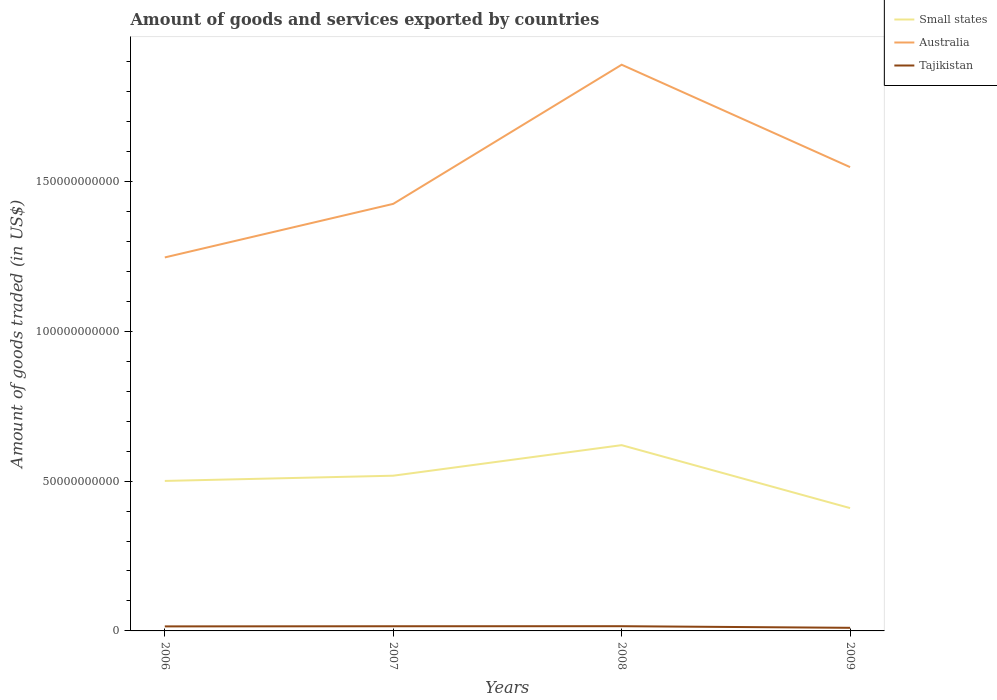How many different coloured lines are there?
Offer a very short reply. 3. Does the line corresponding to Australia intersect with the line corresponding to Small states?
Your answer should be very brief. No. Across all years, what is the maximum total amount of goods and services exported in Tajikistan?
Your answer should be compact. 1.04e+09. In which year was the total amount of goods and services exported in Small states maximum?
Your answer should be very brief. 2009. What is the total total amount of goods and services exported in Australia in the graph?
Offer a very short reply. -6.43e+1. What is the difference between the highest and the second highest total amount of goods and services exported in Tajikistan?
Make the answer very short. 5.36e+08. How many years are there in the graph?
Provide a short and direct response. 4. What is the difference between two consecutive major ticks on the Y-axis?
Your response must be concise. 5.00e+1. Does the graph contain any zero values?
Make the answer very short. No. Where does the legend appear in the graph?
Give a very brief answer. Top right. How many legend labels are there?
Offer a terse response. 3. How are the legend labels stacked?
Make the answer very short. Vertical. What is the title of the graph?
Offer a very short reply. Amount of goods and services exported by countries. Does "Sri Lanka" appear as one of the legend labels in the graph?
Give a very brief answer. No. What is the label or title of the Y-axis?
Your response must be concise. Amount of goods traded (in US$). What is the Amount of goods traded (in US$) of Small states in 2006?
Offer a very short reply. 5.01e+1. What is the Amount of goods traded (in US$) of Australia in 2006?
Provide a succinct answer. 1.25e+11. What is the Amount of goods traded (in US$) of Tajikistan in 2006?
Keep it short and to the point. 1.51e+09. What is the Amount of goods traded (in US$) of Small states in 2007?
Ensure brevity in your answer.  5.18e+1. What is the Amount of goods traded (in US$) of Australia in 2007?
Your response must be concise. 1.43e+11. What is the Amount of goods traded (in US$) in Tajikistan in 2007?
Keep it short and to the point. 1.56e+09. What is the Amount of goods traded (in US$) of Small states in 2008?
Keep it short and to the point. 6.20e+1. What is the Amount of goods traded (in US$) in Australia in 2008?
Your answer should be very brief. 1.89e+11. What is the Amount of goods traded (in US$) of Tajikistan in 2008?
Ensure brevity in your answer.  1.57e+09. What is the Amount of goods traded (in US$) of Small states in 2009?
Your answer should be compact. 4.10e+1. What is the Amount of goods traded (in US$) of Australia in 2009?
Your answer should be compact. 1.55e+11. What is the Amount of goods traded (in US$) in Tajikistan in 2009?
Provide a succinct answer. 1.04e+09. Across all years, what is the maximum Amount of goods traded (in US$) in Small states?
Make the answer very short. 6.20e+1. Across all years, what is the maximum Amount of goods traded (in US$) in Australia?
Your response must be concise. 1.89e+11. Across all years, what is the maximum Amount of goods traded (in US$) in Tajikistan?
Your answer should be very brief. 1.57e+09. Across all years, what is the minimum Amount of goods traded (in US$) of Small states?
Provide a short and direct response. 4.10e+1. Across all years, what is the minimum Amount of goods traded (in US$) in Australia?
Ensure brevity in your answer.  1.25e+11. Across all years, what is the minimum Amount of goods traded (in US$) in Tajikistan?
Offer a terse response. 1.04e+09. What is the total Amount of goods traded (in US$) of Small states in the graph?
Provide a succinct answer. 2.05e+11. What is the total Amount of goods traded (in US$) in Australia in the graph?
Provide a succinct answer. 6.11e+11. What is the total Amount of goods traded (in US$) of Tajikistan in the graph?
Your answer should be compact. 5.68e+09. What is the difference between the Amount of goods traded (in US$) in Small states in 2006 and that in 2007?
Offer a terse response. -1.74e+09. What is the difference between the Amount of goods traded (in US$) of Australia in 2006 and that in 2007?
Make the answer very short. -1.79e+1. What is the difference between the Amount of goods traded (in US$) of Tajikistan in 2006 and that in 2007?
Provide a succinct answer. -4.51e+07. What is the difference between the Amount of goods traded (in US$) in Small states in 2006 and that in 2008?
Offer a very short reply. -1.19e+1. What is the difference between the Amount of goods traded (in US$) in Australia in 2006 and that in 2008?
Provide a short and direct response. -6.43e+1. What is the difference between the Amount of goods traded (in US$) in Tajikistan in 2006 and that in 2008?
Your answer should be compact. -6.31e+07. What is the difference between the Amount of goods traded (in US$) of Small states in 2006 and that in 2009?
Provide a short and direct response. 9.06e+09. What is the difference between the Amount of goods traded (in US$) in Australia in 2006 and that in 2009?
Keep it short and to the point. -3.01e+1. What is the difference between the Amount of goods traded (in US$) in Tajikistan in 2006 and that in 2009?
Your answer should be compact. 4.73e+08. What is the difference between the Amount of goods traded (in US$) of Small states in 2007 and that in 2008?
Ensure brevity in your answer.  -1.02e+1. What is the difference between the Amount of goods traded (in US$) in Australia in 2007 and that in 2008?
Give a very brief answer. -4.64e+1. What is the difference between the Amount of goods traded (in US$) of Tajikistan in 2007 and that in 2008?
Give a very brief answer. -1.80e+07. What is the difference between the Amount of goods traded (in US$) of Small states in 2007 and that in 2009?
Your response must be concise. 1.08e+1. What is the difference between the Amount of goods traded (in US$) in Australia in 2007 and that in 2009?
Keep it short and to the point. -1.23e+1. What is the difference between the Amount of goods traded (in US$) of Tajikistan in 2007 and that in 2009?
Your response must be concise. 5.18e+08. What is the difference between the Amount of goods traded (in US$) of Small states in 2008 and that in 2009?
Your answer should be compact. 2.10e+1. What is the difference between the Amount of goods traded (in US$) in Australia in 2008 and that in 2009?
Provide a succinct answer. 3.42e+1. What is the difference between the Amount of goods traded (in US$) of Tajikistan in 2008 and that in 2009?
Keep it short and to the point. 5.36e+08. What is the difference between the Amount of goods traded (in US$) in Small states in 2006 and the Amount of goods traded (in US$) in Australia in 2007?
Your answer should be very brief. -9.25e+1. What is the difference between the Amount of goods traded (in US$) in Small states in 2006 and the Amount of goods traded (in US$) in Tajikistan in 2007?
Keep it short and to the point. 4.85e+1. What is the difference between the Amount of goods traded (in US$) in Australia in 2006 and the Amount of goods traded (in US$) in Tajikistan in 2007?
Offer a very short reply. 1.23e+11. What is the difference between the Amount of goods traded (in US$) of Small states in 2006 and the Amount of goods traded (in US$) of Australia in 2008?
Provide a short and direct response. -1.39e+11. What is the difference between the Amount of goods traded (in US$) of Small states in 2006 and the Amount of goods traded (in US$) of Tajikistan in 2008?
Ensure brevity in your answer.  4.85e+1. What is the difference between the Amount of goods traded (in US$) in Australia in 2006 and the Amount of goods traded (in US$) in Tajikistan in 2008?
Provide a short and direct response. 1.23e+11. What is the difference between the Amount of goods traded (in US$) in Small states in 2006 and the Amount of goods traded (in US$) in Australia in 2009?
Your answer should be very brief. -1.05e+11. What is the difference between the Amount of goods traded (in US$) in Small states in 2006 and the Amount of goods traded (in US$) in Tajikistan in 2009?
Give a very brief answer. 4.90e+1. What is the difference between the Amount of goods traded (in US$) in Australia in 2006 and the Amount of goods traded (in US$) in Tajikistan in 2009?
Provide a short and direct response. 1.24e+11. What is the difference between the Amount of goods traded (in US$) of Small states in 2007 and the Amount of goods traded (in US$) of Australia in 2008?
Make the answer very short. -1.37e+11. What is the difference between the Amount of goods traded (in US$) in Small states in 2007 and the Amount of goods traded (in US$) in Tajikistan in 2008?
Make the answer very short. 5.02e+1. What is the difference between the Amount of goods traded (in US$) in Australia in 2007 and the Amount of goods traded (in US$) in Tajikistan in 2008?
Your answer should be very brief. 1.41e+11. What is the difference between the Amount of goods traded (in US$) of Small states in 2007 and the Amount of goods traded (in US$) of Australia in 2009?
Keep it short and to the point. -1.03e+11. What is the difference between the Amount of goods traded (in US$) of Small states in 2007 and the Amount of goods traded (in US$) of Tajikistan in 2009?
Offer a very short reply. 5.08e+1. What is the difference between the Amount of goods traded (in US$) in Australia in 2007 and the Amount of goods traded (in US$) in Tajikistan in 2009?
Provide a succinct answer. 1.41e+11. What is the difference between the Amount of goods traded (in US$) in Small states in 2008 and the Amount of goods traded (in US$) in Australia in 2009?
Provide a short and direct response. -9.28e+1. What is the difference between the Amount of goods traded (in US$) in Small states in 2008 and the Amount of goods traded (in US$) in Tajikistan in 2009?
Your answer should be very brief. 6.10e+1. What is the difference between the Amount of goods traded (in US$) in Australia in 2008 and the Amount of goods traded (in US$) in Tajikistan in 2009?
Provide a succinct answer. 1.88e+11. What is the average Amount of goods traded (in US$) in Small states per year?
Provide a succinct answer. 5.12e+1. What is the average Amount of goods traded (in US$) of Australia per year?
Offer a very short reply. 1.53e+11. What is the average Amount of goods traded (in US$) in Tajikistan per year?
Your answer should be very brief. 1.42e+09. In the year 2006, what is the difference between the Amount of goods traded (in US$) of Small states and Amount of goods traded (in US$) of Australia?
Keep it short and to the point. -7.46e+1. In the year 2006, what is the difference between the Amount of goods traded (in US$) of Small states and Amount of goods traded (in US$) of Tajikistan?
Keep it short and to the point. 4.85e+1. In the year 2006, what is the difference between the Amount of goods traded (in US$) of Australia and Amount of goods traded (in US$) of Tajikistan?
Make the answer very short. 1.23e+11. In the year 2007, what is the difference between the Amount of goods traded (in US$) of Small states and Amount of goods traded (in US$) of Australia?
Keep it short and to the point. -9.07e+1. In the year 2007, what is the difference between the Amount of goods traded (in US$) in Small states and Amount of goods traded (in US$) in Tajikistan?
Make the answer very short. 5.02e+1. In the year 2007, what is the difference between the Amount of goods traded (in US$) of Australia and Amount of goods traded (in US$) of Tajikistan?
Offer a very short reply. 1.41e+11. In the year 2008, what is the difference between the Amount of goods traded (in US$) of Small states and Amount of goods traded (in US$) of Australia?
Ensure brevity in your answer.  -1.27e+11. In the year 2008, what is the difference between the Amount of goods traded (in US$) in Small states and Amount of goods traded (in US$) in Tajikistan?
Provide a short and direct response. 6.04e+1. In the year 2008, what is the difference between the Amount of goods traded (in US$) of Australia and Amount of goods traded (in US$) of Tajikistan?
Give a very brief answer. 1.87e+11. In the year 2009, what is the difference between the Amount of goods traded (in US$) in Small states and Amount of goods traded (in US$) in Australia?
Offer a terse response. -1.14e+11. In the year 2009, what is the difference between the Amount of goods traded (in US$) in Small states and Amount of goods traded (in US$) in Tajikistan?
Provide a succinct answer. 4.00e+1. In the year 2009, what is the difference between the Amount of goods traded (in US$) in Australia and Amount of goods traded (in US$) in Tajikistan?
Offer a very short reply. 1.54e+11. What is the ratio of the Amount of goods traded (in US$) in Small states in 2006 to that in 2007?
Your answer should be compact. 0.97. What is the ratio of the Amount of goods traded (in US$) of Australia in 2006 to that in 2007?
Provide a short and direct response. 0.87. What is the ratio of the Amount of goods traded (in US$) of Small states in 2006 to that in 2008?
Make the answer very short. 0.81. What is the ratio of the Amount of goods traded (in US$) of Australia in 2006 to that in 2008?
Give a very brief answer. 0.66. What is the ratio of the Amount of goods traded (in US$) of Tajikistan in 2006 to that in 2008?
Your response must be concise. 0.96. What is the ratio of the Amount of goods traded (in US$) of Small states in 2006 to that in 2009?
Make the answer very short. 1.22. What is the ratio of the Amount of goods traded (in US$) in Australia in 2006 to that in 2009?
Keep it short and to the point. 0.81. What is the ratio of the Amount of goods traded (in US$) in Tajikistan in 2006 to that in 2009?
Offer a very short reply. 1.46. What is the ratio of the Amount of goods traded (in US$) of Small states in 2007 to that in 2008?
Keep it short and to the point. 0.84. What is the ratio of the Amount of goods traded (in US$) of Australia in 2007 to that in 2008?
Keep it short and to the point. 0.75. What is the ratio of the Amount of goods traded (in US$) in Small states in 2007 to that in 2009?
Offer a terse response. 1.26. What is the ratio of the Amount of goods traded (in US$) in Australia in 2007 to that in 2009?
Offer a terse response. 0.92. What is the ratio of the Amount of goods traded (in US$) of Tajikistan in 2007 to that in 2009?
Provide a short and direct response. 1.5. What is the ratio of the Amount of goods traded (in US$) in Small states in 2008 to that in 2009?
Offer a very short reply. 1.51. What is the ratio of the Amount of goods traded (in US$) of Australia in 2008 to that in 2009?
Provide a short and direct response. 1.22. What is the ratio of the Amount of goods traded (in US$) of Tajikistan in 2008 to that in 2009?
Give a very brief answer. 1.52. What is the difference between the highest and the second highest Amount of goods traded (in US$) of Small states?
Ensure brevity in your answer.  1.02e+1. What is the difference between the highest and the second highest Amount of goods traded (in US$) in Australia?
Provide a short and direct response. 3.42e+1. What is the difference between the highest and the second highest Amount of goods traded (in US$) in Tajikistan?
Provide a short and direct response. 1.80e+07. What is the difference between the highest and the lowest Amount of goods traded (in US$) of Small states?
Make the answer very short. 2.10e+1. What is the difference between the highest and the lowest Amount of goods traded (in US$) of Australia?
Make the answer very short. 6.43e+1. What is the difference between the highest and the lowest Amount of goods traded (in US$) of Tajikistan?
Ensure brevity in your answer.  5.36e+08. 